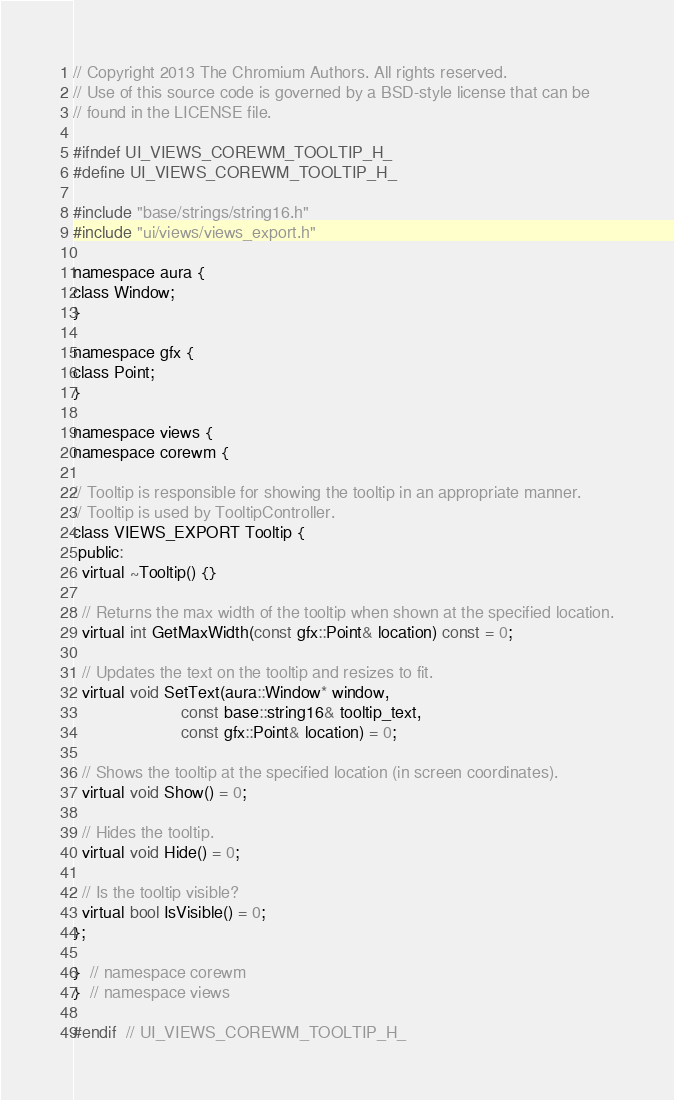Convert code to text. <code><loc_0><loc_0><loc_500><loc_500><_C_>// Copyright 2013 The Chromium Authors. All rights reserved.
// Use of this source code is governed by a BSD-style license that can be
// found in the LICENSE file.

#ifndef UI_VIEWS_COREWM_TOOLTIP_H_
#define UI_VIEWS_COREWM_TOOLTIP_H_

#include "base/strings/string16.h"
#include "ui/views/views_export.h"

namespace aura {
class Window;
}

namespace gfx {
class Point;
}

namespace views {
namespace corewm {

// Tooltip is responsible for showing the tooltip in an appropriate manner.
// Tooltip is used by TooltipController.
class VIEWS_EXPORT Tooltip {
 public:
  virtual ~Tooltip() {}

  // Returns the max width of the tooltip when shown at the specified location.
  virtual int GetMaxWidth(const gfx::Point& location) const = 0;

  // Updates the text on the tooltip and resizes to fit.
  virtual void SetText(aura::Window* window,
                       const base::string16& tooltip_text,
                       const gfx::Point& location) = 0;

  // Shows the tooltip at the specified location (in screen coordinates).
  virtual void Show() = 0;

  // Hides the tooltip.
  virtual void Hide() = 0;

  // Is the tooltip visible?
  virtual bool IsVisible() = 0;
};

}  // namespace corewm
}  // namespace views

#endif  // UI_VIEWS_COREWM_TOOLTIP_H_
</code> 